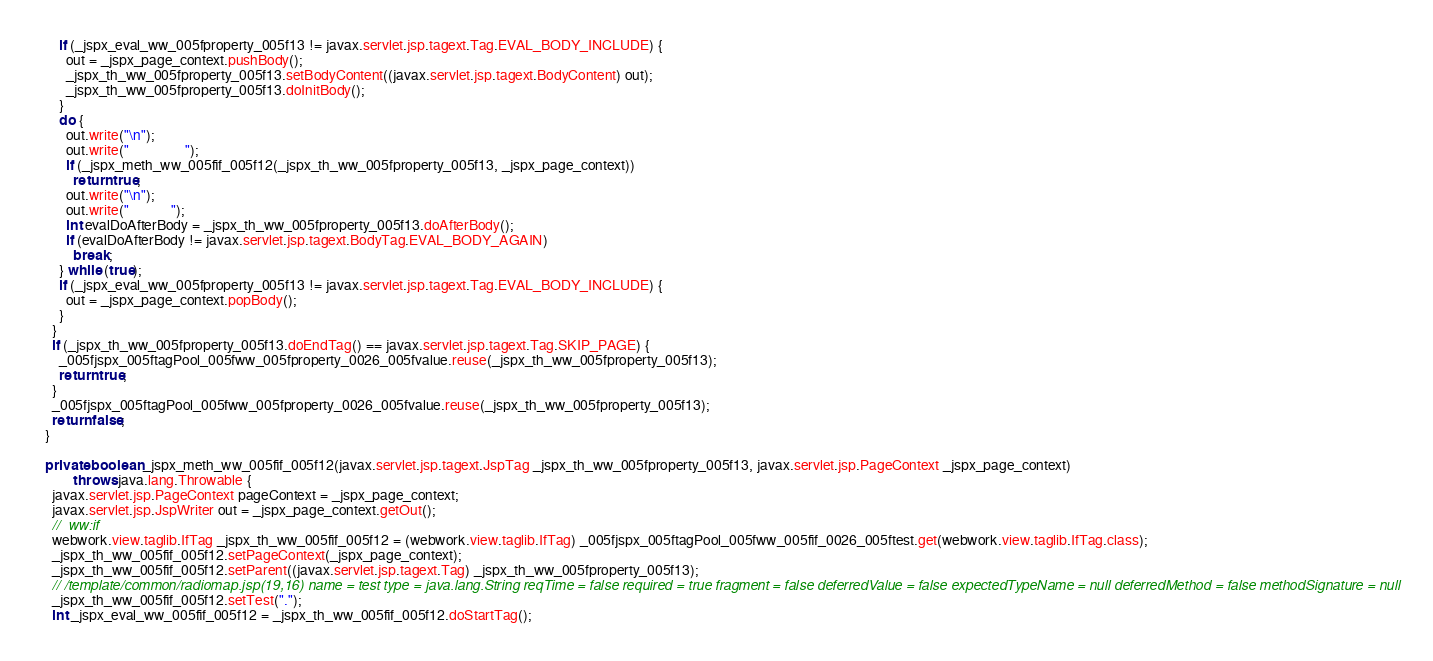Convert code to text. <code><loc_0><loc_0><loc_500><loc_500><_Java_>      if (_jspx_eval_ww_005fproperty_005f13 != javax.servlet.jsp.tagext.Tag.EVAL_BODY_INCLUDE) {
        out = _jspx_page_context.pushBody();
        _jspx_th_ww_005fproperty_005f13.setBodyContent((javax.servlet.jsp.tagext.BodyContent) out);
        _jspx_th_ww_005fproperty_005f13.doInitBody();
      }
      do {
        out.write("\n");
        out.write("                ");
        if (_jspx_meth_ww_005fif_005f12(_jspx_th_ww_005fproperty_005f13, _jspx_page_context))
          return true;
        out.write("\n");
        out.write("            ");
        int evalDoAfterBody = _jspx_th_ww_005fproperty_005f13.doAfterBody();
        if (evalDoAfterBody != javax.servlet.jsp.tagext.BodyTag.EVAL_BODY_AGAIN)
          break;
      } while (true);
      if (_jspx_eval_ww_005fproperty_005f13 != javax.servlet.jsp.tagext.Tag.EVAL_BODY_INCLUDE) {
        out = _jspx_page_context.popBody();
      }
    }
    if (_jspx_th_ww_005fproperty_005f13.doEndTag() == javax.servlet.jsp.tagext.Tag.SKIP_PAGE) {
      _005fjspx_005ftagPool_005fww_005fproperty_0026_005fvalue.reuse(_jspx_th_ww_005fproperty_005f13);
      return true;
    }
    _005fjspx_005ftagPool_005fww_005fproperty_0026_005fvalue.reuse(_jspx_th_ww_005fproperty_005f13);
    return false;
  }

  private boolean _jspx_meth_ww_005fif_005f12(javax.servlet.jsp.tagext.JspTag _jspx_th_ww_005fproperty_005f13, javax.servlet.jsp.PageContext _jspx_page_context)
          throws java.lang.Throwable {
    javax.servlet.jsp.PageContext pageContext = _jspx_page_context;
    javax.servlet.jsp.JspWriter out = _jspx_page_context.getOut();
    //  ww:if
    webwork.view.taglib.IfTag _jspx_th_ww_005fif_005f12 = (webwork.view.taglib.IfTag) _005fjspx_005ftagPool_005fww_005fif_0026_005ftest.get(webwork.view.taglib.IfTag.class);
    _jspx_th_ww_005fif_005f12.setPageContext(_jspx_page_context);
    _jspx_th_ww_005fif_005f12.setParent((javax.servlet.jsp.tagext.Tag) _jspx_th_ww_005fproperty_005f13);
    // /template/common/radiomap.jsp(19,16) name = test type = java.lang.String reqTime = false required = true fragment = false deferredValue = false expectedTypeName = null deferredMethod = false methodSignature = null
    _jspx_th_ww_005fif_005f12.setTest(".");
    int _jspx_eval_ww_005fif_005f12 = _jspx_th_ww_005fif_005f12.doStartTag();</code> 